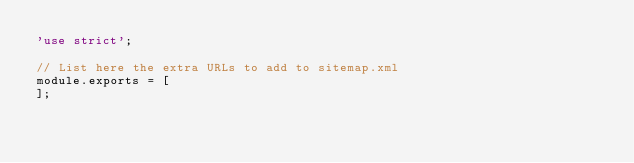<code> <loc_0><loc_0><loc_500><loc_500><_JavaScript_>'use strict';

// List here the extra URLs to add to sitemap.xml
module.exports = [
];
</code> 